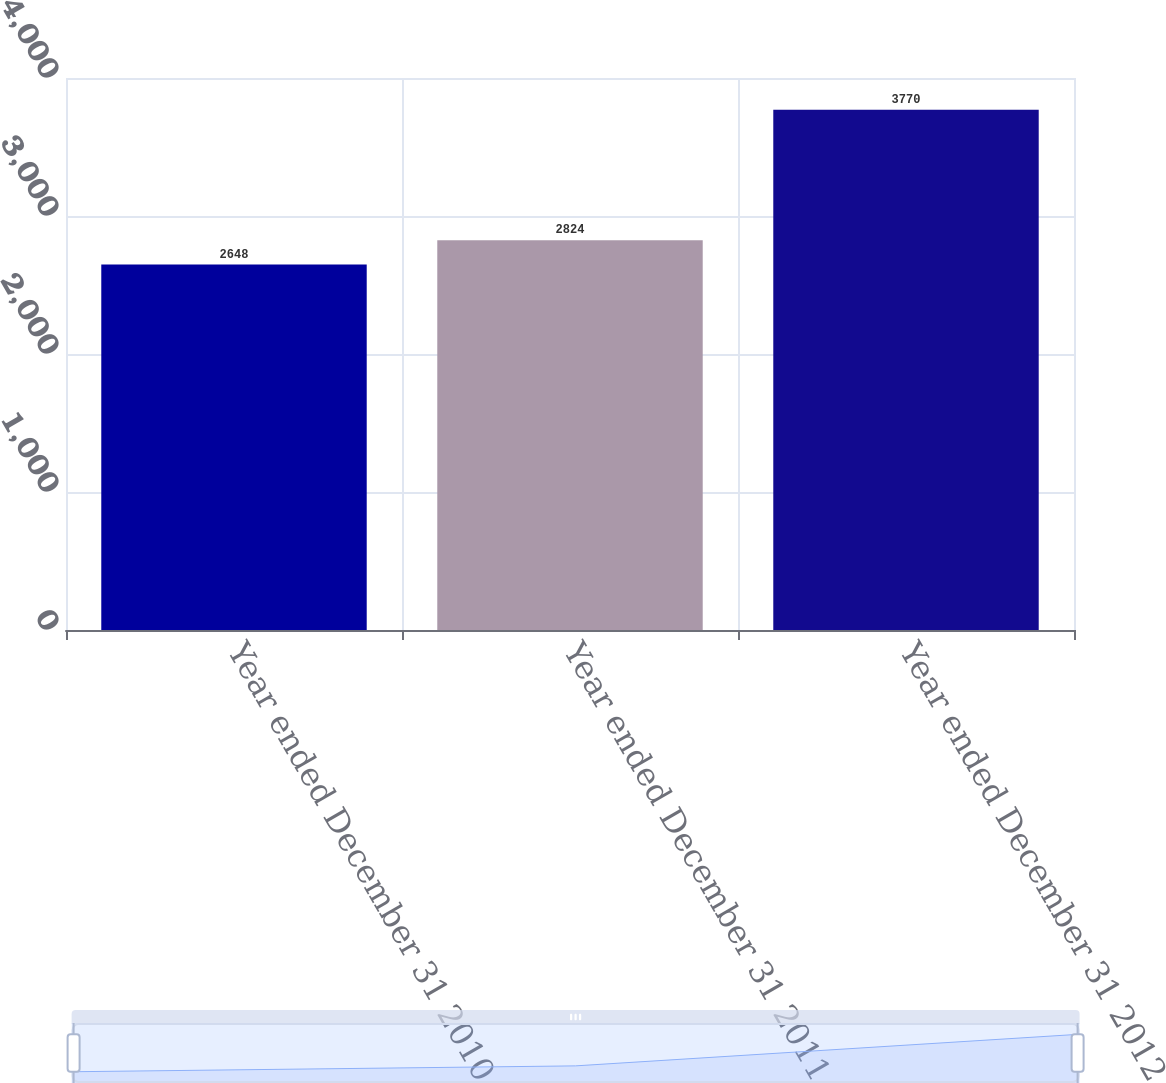<chart> <loc_0><loc_0><loc_500><loc_500><bar_chart><fcel>Year ended December 31 2010<fcel>Year ended December 31 2011<fcel>Year ended December 31 2012<nl><fcel>2648<fcel>2824<fcel>3770<nl></chart> 